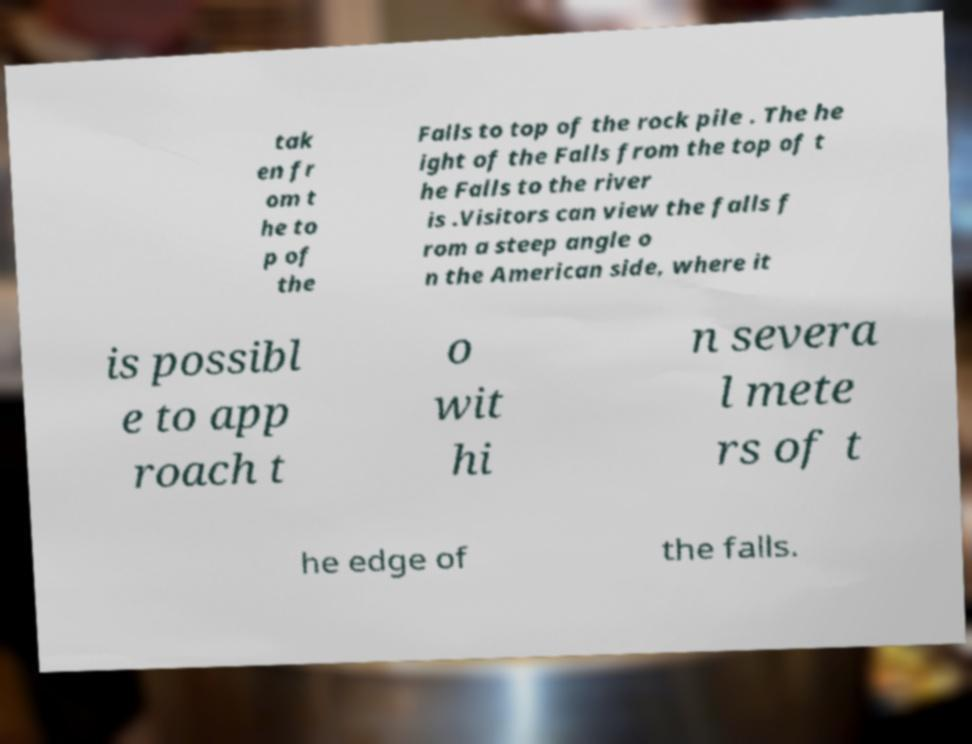Can you accurately transcribe the text from the provided image for me? tak en fr om t he to p of the Falls to top of the rock pile . The he ight of the Falls from the top of t he Falls to the river is .Visitors can view the falls f rom a steep angle o n the American side, where it is possibl e to app roach t o wit hi n severa l mete rs of t he edge of the falls. 